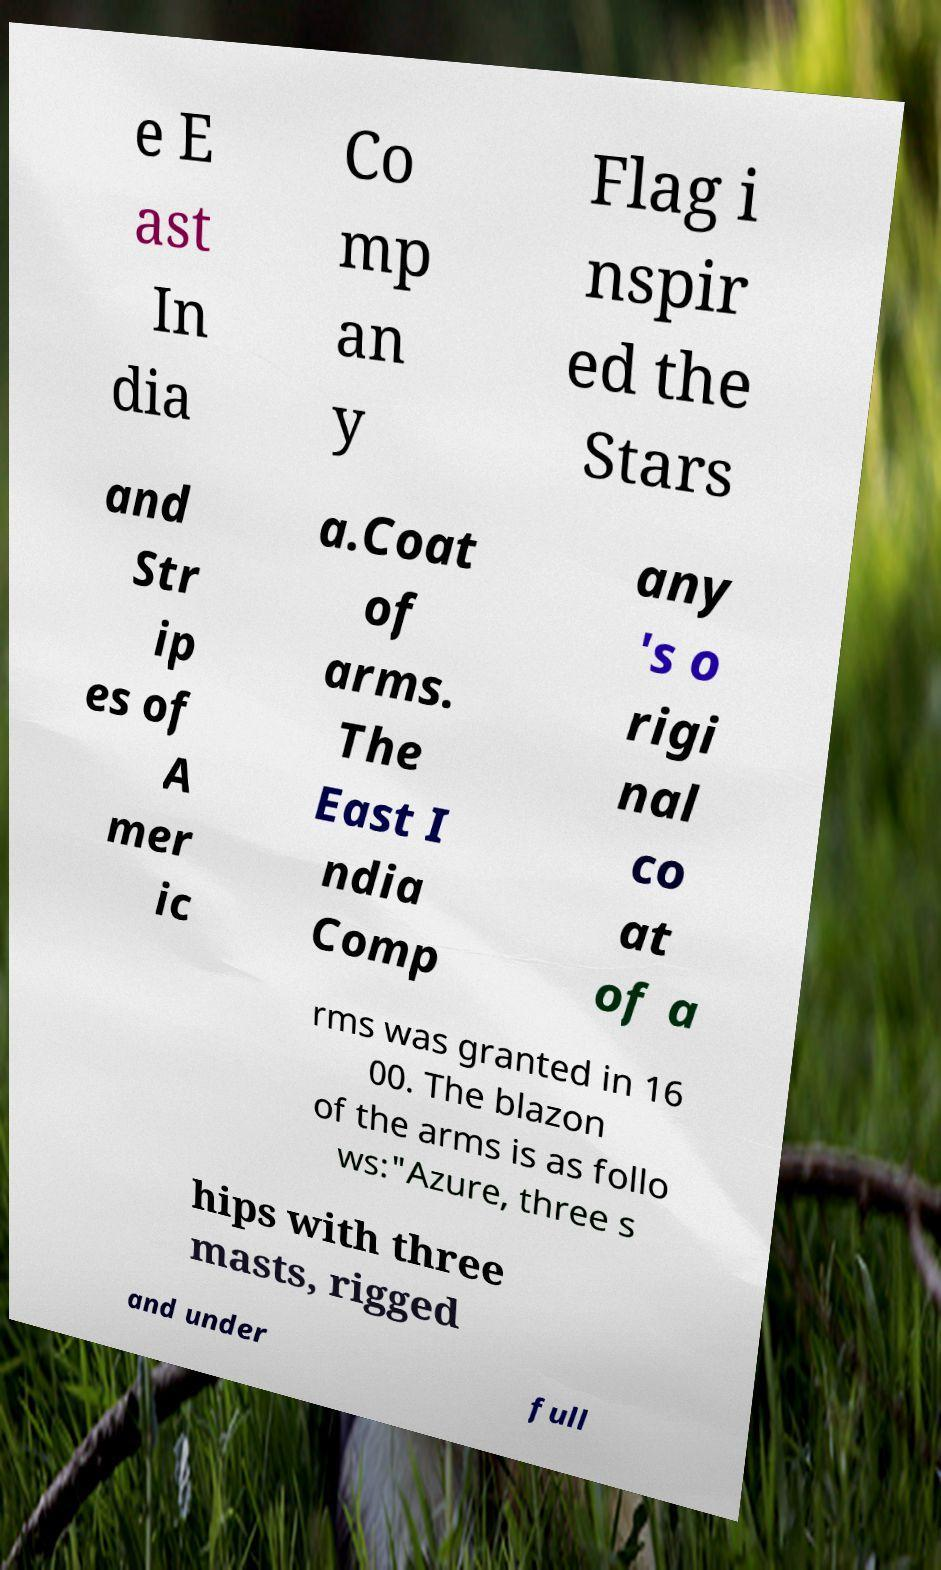Please read and relay the text visible in this image. What does it say? e E ast In dia Co mp an y Flag i nspir ed the Stars and Str ip es of A mer ic a.Coat of arms. The East I ndia Comp any 's o rigi nal co at of a rms was granted in 16 00. The blazon of the arms is as follo ws:"Azure, three s hips with three masts, rigged and under full 